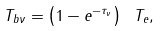<formula> <loc_0><loc_0><loc_500><loc_500>T _ { b \nu } = \left ( 1 - e ^ { - \tau _ { \nu } } \right ) \ T _ { e } ,</formula> 